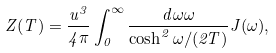<formula> <loc_0><loc_0><loc_500><loc_500>Z ( T ) = \frac { u ^ { 3 } } { 4 \pi } \int _ { 0 } ^ { \infty } \frac { d \omega \omega } { \cosh ^ { 2 } \omega / ( 2 T ) } J ( \omega ) ,</formula> 